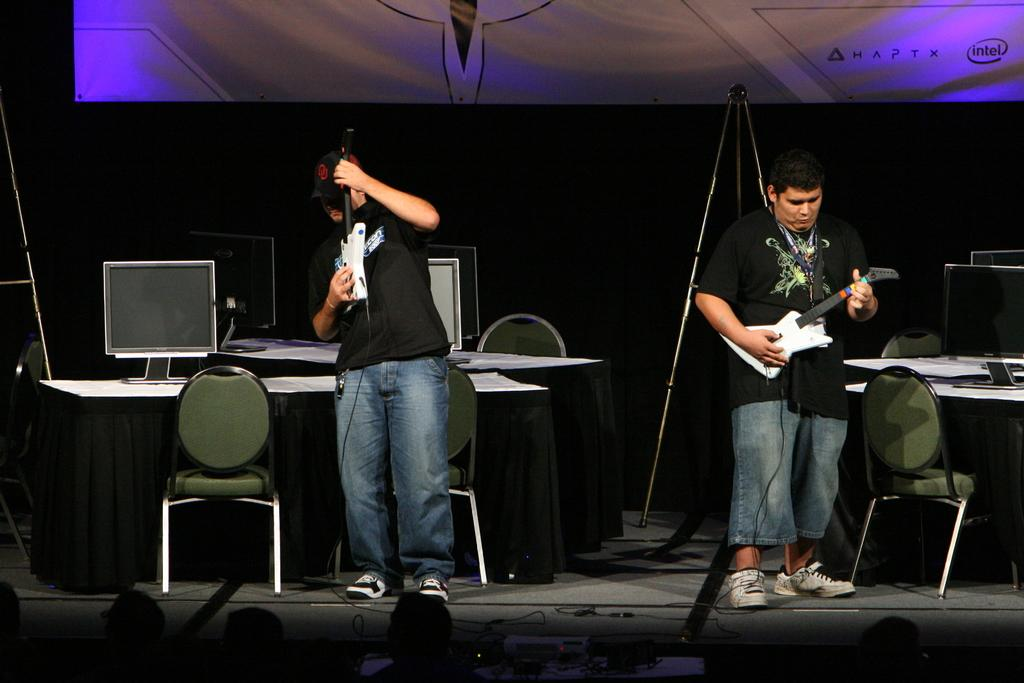How many people are in the image? There are two men in the image. What are the men doing in the image? The men are playing a guitar. Where are the men located in the image? The men are on a dais. What else can be seen in the image? There are chairs visible in the image. What type of machine is the men using to talk in the image? There is no machine present in the image, and the men are not using any device to communicate. 